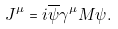<formula> <loc_0><loc_0><loc_500><loc_500>J ^ { \mu } = i \overline { \psi } \gamma ^ { \mu } M \psi .</formula> 